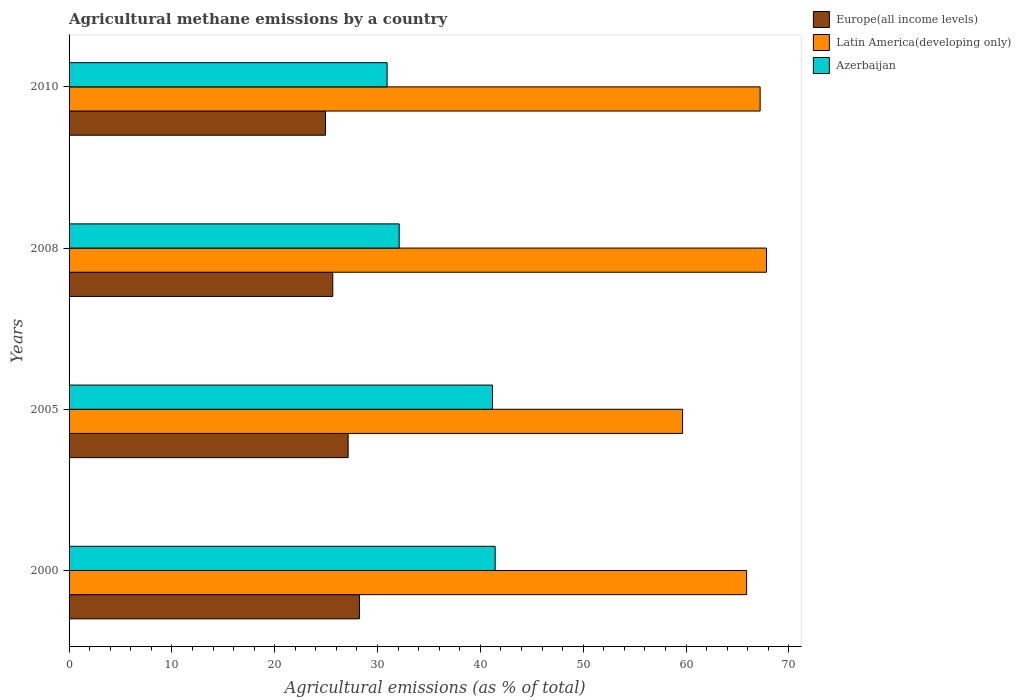What is the amount of agricultural methane emitted in Latin America(developing only) in 2000?
Your response must be concise. 65.9. Across all years, what is the maximum amount of agricultural methane emitted in Latin America(developing only)?
Your answer should be very brief. 67.83. Across all years, what is the minimum amount of agricultural methane emitted in Latin America(developing only)?
Your response must be concise. 59.67. What is the total amount of agricultural methane emitted in Azerbaijan in the graph?
Ensure brevity in your answer.  145.65. What is the difference between the amount of agricultural methane emitted in Latin America(developing only) in 2000 and that in 2010?
Your answer should be compact. -1.31. What is the difference between the amount of agricultural methane emitted in Azerbaijan in 2005 and the amount of agricultural methane emitted in Latin America(developing only) in 2000?
Ensure brevity in your answer.  -24.72. What is the average amount of agricultural methane emitted in Latin America(developing only) per year?
Keep it short and to the point. 65.15. In the year 2000, what is the difference between the amount of agricultural methane emitted in Azerbaijan and amount of agricultural methane emitted in Latin America(developing only)?
Your answer should be very brief. -24.46. What is the ratio of the amount of agricultural methane emitted in Europe(all income levels) in 2000 to that in 2008?
Keep it short and to the point. 1.1. Is the amount of agricultural methane emitted in Azerbaijan in 2000 less than that in 2008?
Make the answer very short. No. What is the difference between the highest and the second highest amount of agricultural methane emitted in Europe(all income levels)?
Your response must be concise. 1.1. What is the difference between the highest and the lowest amount of agricultural methane emitted in Azerbaijan?
Give a very brief answer. 10.51. What does the 2nd bar from the top in 2008 represents?
Provide a succinct answer. Latin America(developing only). What does the 3rd bar from the bottom in 2008 represents?
Provide a short and direct response. Azerbaijan. Are all the bars in the graph horizontal?
Keep it short and to the point. Yes. Does the graph contain grids?
Provide a succinct answer. No. Where does the legend appear in the graph?
Ensure brevity in your answer.  Top right. What is the title of the graph?
Give a very brief answer. Agricultural methane emissions by a country. Does "Angola" appear as one of the legend labels in the graph?
Provide a short and direct response. No. What is the label or title of the X-axis?
Provide a short and direct response. Agricultural emissions (as % of total). What is the label or title of the Y-axis?
Your answer should be compact. Years. What is the Agricultural emissions (as % of total) of Europe(all income levels) in 2000?
Keep it short and to the point. 28.24. What is the Agricultural emissions (as % of total) in Latin America(developing only) in 2000?
Your answer should be very brief. 65.9. What is the Agricultural emissions (as % of total) in Azerbaijan in 2000?
Your response must be concise. 41.44. What is the Agricultural emissions (as % of total) of Europe(all income levels) in 2005?
Give a very brief answer. 27.14. What is the Agricultural emissions (as % of total) in Latin America(developing only) in 2005?
Your answer should be very brief. 59.67. What is the Agricultural emissions (as % of total) in Azerbaijan in 2005?
Offer a very short reply. 41.18. What is the Agricultural emissions (as % of total) in Europe(all income levels) in 2008?
Your answer should be very brief. 25.65. What is the Agricultural emissions (as % of total) in Latin America(developing only) in 2008?
Offer a terse response. 67.83. What is the Agricultural emissions (as % of total) in Azerbaijan in 2008?
Your response must be concise. 32.1. What is the Agricultural emissions (as % of total) of Europe(all income levels) in 2010?
Provide a short and direct response. 24.94. What is the Agricultural emissions (as % of total) of Latin America(developing only) in 2010?
Your answer should be compact. 67.21. What is the Agricultural emissions (as % of total) in Azerbaijan in 2010?
Your answer should be compact. 30.93. Across all years, what is the maximum Agricultural emissions (as % of total) in Europe(all income levels)?
Offer a very short reply. 28.24. Across all years, what is the maximum Agricultural emissions (as % of total) of Latin America(developing only)?
Give a very brief answer. 67.83. Across all years, what is the maximum Agricultural emissions (as % of total) of Azerbaijan?
Keep it short and to the point. 41.44. Across all years, what is the minimum Agricultural emissions (as % of total) in Europe(all income levels)?
Offer a terse response. 24.94. Across all years, what is the minimum Agricultural emissions (as % of total) of Latin America(developing only)?
Provide a short and direct response. 59.67. Across all years, what is the minimum Agricultural emissions (as % of total) in Azerbaijan?
Offer a very short reply. 30.93. What is the total Agricultural emissions (as % of total) in Europe(all income levels) in the graph?
Your answer should be compact. 105.97. What is the total Agricultural emissions (as % of total) in Latin America(developing only) in the graph?
Provide a succinct answer. 260.6. What is the total Agricultural emissions (as % of total) of Azerbaijan in the graph?
Provide a succinct answer. 145.65. What is the difference between the Agricultural emissions (as % of total) in Europe(all income levels) in 2000 and that in 2005?
Make the answer very short. 1.1. What is the difference between the Agricultural emissions (as % of total) of Latin America(developing only) in 2000 and that in 2005?
Give a very brief answer. 6.23. What is the difference between the Agricultural emissions (as % of total) in Azerbaijan in 2000 and that in 2005?
Offer a terse response. 0.26. What is the difference between the Agricultural emissions (as % of total) of Europe(all income levels) in 2000 and that in 2008?
Give a very brief answer. 2.59. What is the difference between the Agricultural emissions (as % of total) of Latin America(developing only) in 2000 and that in 2008?
Keep it short and to the point. -1.93. What is the difference between the Agricultural emissions (as % of total) of Azerbaijan in 2000 and that in 2008?
Ensure brevity in your answer.  9.33. What is the difference between the Agricultural emissions (as % of total) of Europe(all income levels) in 2000 and that in 2010?
Ensure brevity in your answer.  3.3. What is the difference between the Agricultural emissions (as % of total) of Latin America(developing only) in 2000 and that in 2010?
Offer a terse response. -1.31. What is the difference between the Agricultural emissions (as % of total) of Azerbaijan in 2000 and that in 2010?
Make the answer very short. 10.51. What is the difference between the Agricultural emissions (as % of total) of Europe(all income levels) in 2005 and that in 2008?
Your answer should be compact. 1.5. What is the difference between the Agricultural emissions (as % of total) in Latin America(developing only) in 2005 and that in 2008?
Offer a terse response. -8.16. What is the difference between the Agricultural emissions (as % of total) of Azerbaijan in 2005 and that in 2008?
Keep it short and to the point. 9.07. What is the difference between the Agricultural emissions (as % of total) in Europe(all income levels) in 2005 and that in 2010?
Make the answer very short. 2.2. What is the difference between the Agricultural emissions (as % of total) in Latin America(developing only) in 2005 and that in 2010?
Your response must be concise. -7.54. What is the difference between the Agricultural emissions (as % of total) of Azerbaijan in 2005 and that in 2010?
Your answer should be compact. 10.25. What is the difference between the Agricultural emissions (as % of total) of Europe(all income levels) in 2008 and that in 2010?
Your response must be concise. 0.71. What is the difference between the Agricultural emissions (as % of total) in Latin America(developing only) in 2008 and that in 2010?
Offer a very short reply. 0.62. What is the difference between the Agricultural emissions (as % of total) in Azerbaijan in 2008 and that in 2010?
Make the answer very short. 1.17. What is the difference between the Agricultural emissions (as % of total) of Europe(all income levels) in 2000 and the Agricultural emissions (as % of total) of Latin America(developing only) in 2005?
Provide a succinct answer. -31.43. What is the difference between the Agricultural emissions (as % of total) of Europe(all income levels) in 2000 and the Agricultural emissions (as % of total) of Azerbaijan in 2005?
Offer a very short reply. -12.94. What is the difference between the Agricultural emissions (as % of total) of Latin America(developing only) in 2000 and the Agricultural emissions (as % of total) of Azerbaijan in 2005?
Make the answer very short. 24.72. What is the difference between the Agricultural emissions (as % of total) of Europe(all income levels) in 2000 and the Agricultural emissions (as % of total) of Latin America(developing only) in 2008?
Your response must be concise. -39.59. What is the difference between the Agricultural emissions (as % of total) of Europe(all income levels) in 2000 and the Agricultural emissions (as % of total) of Azerbaijan in 2008?
Offer a very short reply. -3.86. What is the difference between the Agricultural emissions (as % of total) in Latin America(developing only) in 2000 and the Agricultural emissions (as % of total) in Azerbaijan in 2008?
Make the answer very short. 33.79. What is the difference between the Agricultural emissions (as % of total) of Europe(all income levels) in 2000 and the Agricultural emissions (as % of total) of Latin America(developing only) in 2010?
Keep it short and to the point. -38.97. What is the difference between the Agricultural emissions (as % of total) of Europe(all income levels) in 2000 and the Agricultural emissions (as % of total) of Azerbaijan in 2010?
Provide a short and direct response. -2.69. What is the difference between the Agricultural emissions (as % of total) of Latin America(developing only) in 2000 and the Agricultural emissions (as % of total) of Azerbaijan in 2010?
Provide a short and direct response. 34.97. What is the difference between the Agricultural emissions (as % of total) in Europe(all income levels) in 2005 and the Agricultural emissions (as % of total) in Latin America(developing only) in 2008?
Keep it short and to the point. -40.69. What is the difference between the Agricultural emissions (as % of total) of Europe(all income levels) in 2005 and the Agricultural emissions (as % of total) of Azerbaijan in 2008?
Ensure brevity in your answer.  -4.96. What is the difference between the Agricultural emissions (as % of total) of Latin America(developing only) in 2005 and the Agricultural emissions (as % of total) of Azerbaijan in 2008?
Ensure brevity in your answer.  27.56. What is the difference between the Agricultural emissions (as % of total) in Europe(all income levels) in 2005 and the Agricultural emissions (as % of total) in Latin America(developing only) in 2010?
Keep it short and to the point. -40.07. What is the difference between the Agricultural emissions (as % of total) of Europe(all income levels) in 2005 and the Agricultural emissions (as % of total) of Azerbaijan in 2010?
Your answer should be very brief. -3.79. What is the difference between the Agricultural emissions (as % of total) in Latin America(developing only) in 2005 and the Agricultural emissions (as % of total) in Azerbaijan in 2010?
Keep it short and to the point. 28.74. What is the difference between the Agricultural emissions (as % of total) of Europe(all income levels) in 2008 and the Agricultural emissions (as % of total) of Latin America(developing only) in 2010?
Your response must be concise. -41.56. What is the difference between the Agricultural emissions (as % of total) of Europe(all income levels) in 2008 and the Agricultural emissions (as % of total) of Azerbaijan in 2010?
Make the answer very short. -5.28. What is the difference between the Agricultural emissions (as % of total) in Latin America(developing only) in 2008 and the Agricultural emissions (as % of total) in Azerbaijan in 2010?
Provide a succinct answer. 36.9. What is the average Agricultural emissions (as % of total) of Europe(all income levels) per year?
Offer a terse response. 26.49. What is the average Agricultural emissions (as % of total) of Latin America(developing only) per year?
Your response must be concise. 65.15. What is the average Agricultural emissions (as % of total) in Azerbaijan per year?
Give a very brief answer. 36.41. In the year 2000, what is the difference between the Agricultural emissions (as % of total) of Europe(all income levels) and Agricultural emissions (as % of total) of Latin America(developing only)?
Make the answer very short. -37.66. In the year 2000, what is the difference between the Agricultural emissions (as % of total) in Europe(all income levels) and Agricultural emissions (as % of total) in Azerbaijan?
Ensure brevity in your answer.  -13.2. In the year 2000, what is the difference between the Agricultural emissions (as % of total) of Latin America(developing only) and Agricultural emissions (as % of total) of Azerbaijan?
Your answer should be compact. 24.46. In the year 2005, what is the difference between the Agricultural emissions (as % of total) of Europe(all income levels) and Agricultural emissions (as % of total) of Latin America(developing only)?
Your answer should be compact. -32.53. In the year 2005, what is the difference between the Agricultural emissions (as % of total) in Europe(all income levels) and Agricultural emissions (as % of total) in Azerbaijan?
Offer a very short reply. -14.04. In the year 2005, what is the difference between the Agricultural emissions (as % of total) in Latin America(developing only) and Agricultural emissions (as % of total) in Azerbaijan?
Your answer should be compact. 18.49. In the year 2008, what is the difference between the Agricultural emissions (as % of total) of Europe(all income levels) and Agricultural emissions (as % of total) of Latin America(developing only)?
Your answer should be compact. -42.18. In the year 2008, what is the difference between the Agricultural emissions (as % of total) in Europe(all income levels) and Agricultural emissions (as % of total) in Azerbaijan?
Provide a succinct answer. -6.46. In the year 2008, what is the difference between the Agricultural emissions (as % of total) in Latin America(developing only) and Agricultural emissions (as % of total) in Azerbaijan?
Your answer should be very brief. 35.72. In the year 2010, what is the difference between the Agricultural emissions (as % of total) in Europe(all income levels) and Agricultural emissions (as % of total) in Latin America(developing only)?
Keep it short and to the point. -42.27. In the year 2010, what is the difference between the Agricultural emissions (as % of total) in Europe(all income levels) and Agricultural emissions (as % of total) in Azerbaijan?
Offer a terse response. -5.99. In the year 2010, what is the difference between the Agricultural emissions (as % of total) in Latin America(developing only) and Agricultural emissions (as % of total) in Azerbaijan?
Offer a terse response. 36.28. What is the ratio of the Agricultural emissions (as % of total) in Europe(all income levels) in 2000 to that in 2005?
Offer a very short reply. 1.04. What is the ratio of the Agricultural emissions (as % of total) in Latin America(developing only) in 2000 to that in 2005?
Your answer should be compact. 1.1. What is the ratio of the Agricultural emissions (as % of total) in Azerbaijan in 2000 to that in 2005?
Keep it short and to the point. 1.01. What is the ratio of the Agricultural emissions (as % of total) of Europe(all income levels) in 2000 to that in 2008?
Provide a short and direct response. 1.1. What is the ratio of the Agricultural emissions (as % of total) of Latin America(developing only) in 2000 to that in 2008?
Your answer should be compact. 0.97. What is the ratio of the Agricultural emissions (as % of total) of Azerbaijan in 2000 to that in 2008?
Provide a succinct answer. 1.29. What is the ratio of the Agricultural emissions (as % of total) in Europe(all income levels) in 2000 to that in 2010?
Provide a succinct answer. 1.13. What is the ratio of the Agricultural emissions (as % of total) of Latin America(developing only) in 2000 to that in 2010?
Offer a terse response. 0.98. What is the ratio of the Agricultural emissions (as % of total) in Azerbaijan in 2000 to that in 2010?
Your answer should be compact. 1.34. What is the ratio of the Agricultural emissions (as % of total) in Europe(all income levels) in 2005 to that in 2008?
Your answer should be compact. 1.06. What is the ratio of the Agricultural emissions (as % of total) of Latin America(developing only) in 2005 to that in 2008?
Provide a succinct answer. 0.88. What is the ratio of the Agricultural emissions (as % of total) of Azerbaijan in 2005 to that in 2008?
Ensure brevity in your answer.  1.28. What is the ratio of the Agricultural emissions (as % of total) of Europe(all income levels) in 2005 to that in 2010?
Offer a very short reply. 1.09. What is the ratio of the Agricultural emissions (as % of total) of Latin America(developing only) in 2005 to that in 2010?
Ensure brevity in your answer.  0.89. What is the ratio of the Agricultural emissions (as % of total) of Azerbaijan in 2005 to that in 2010?
Provide a succinct answer. 1.33. What is the ratio of the Agricultural emissions (as % of total) of Europe(all income levels) in 2008 to that in 2010?
Offer a terse response. 1.03. What is the ratio of the Agricultural emissions (as % of total) in Latin America(developing only) in 2008 to that in 2010?
Give a very brief answer. 1.01. What is the ratio of the Agricultural emissions (as % of total) in Azerbaijan in 2008 to that in 2010?
Your response must be concise. 1.04. What is the difference between the highest and the second highest Agricultural emissions (as % of total) of Europe(all income levels)?
Your response must be concise. 1.1. What is the difference between the highest and the second highest Agricultural emissions (as % of total) of Latin America(developing only)?
Offer a very short reply. 0.62. What is the difference between the highest and the second highest Agricultural emissions (as % of total) of Azerbaijan?
Your answer should be very brief. 0.26. What is the difference between the highest and the lowest Agricultural emissions (as % of total) in Europe(all income levels)?
Provide a succinct answer. 3.3. What is the difference between the highest and the lowest Agricultural emissions (as % of total) in Latin America(developing only)?
Keep it short and to the point. 8.16. What is the difference between the highest and the lowest Agricultural emissions (as % of total) in Azerbaijan?
Make the answer very short. 10.51. 